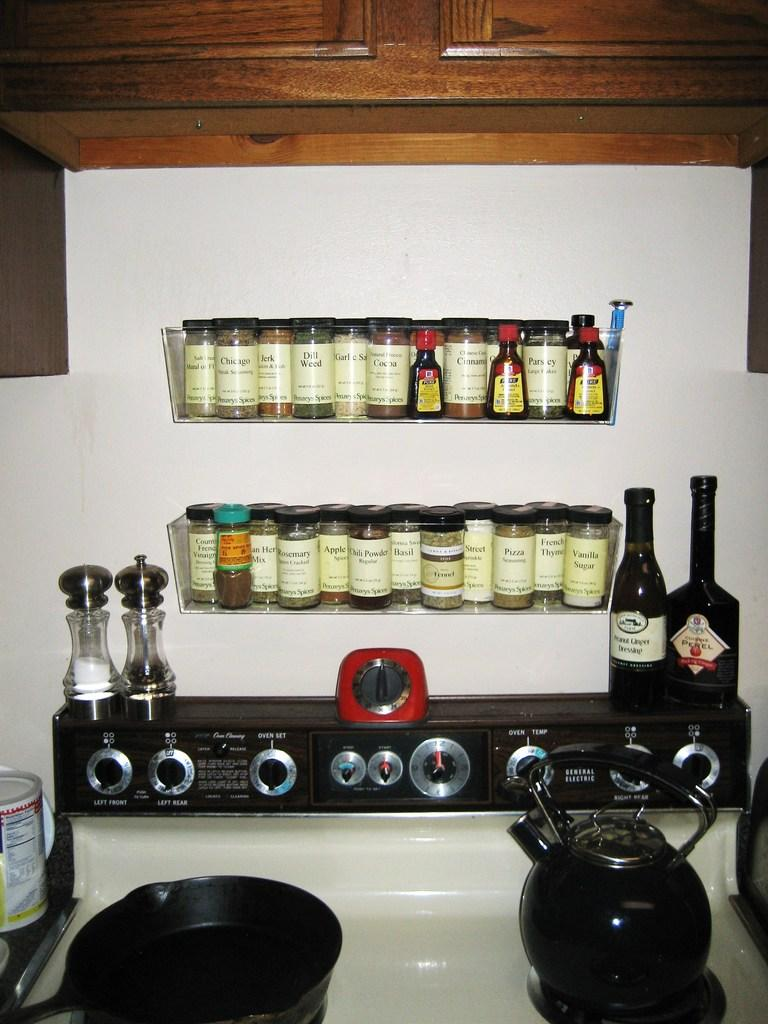<image>
Present a compact description of the photo's key features. If you need dill weed, rosemary, or basil, you can find them on this spice rack. 